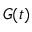<formula> <loc_0><loc_0><loc_500><loc_500>G ( t )</formula> 